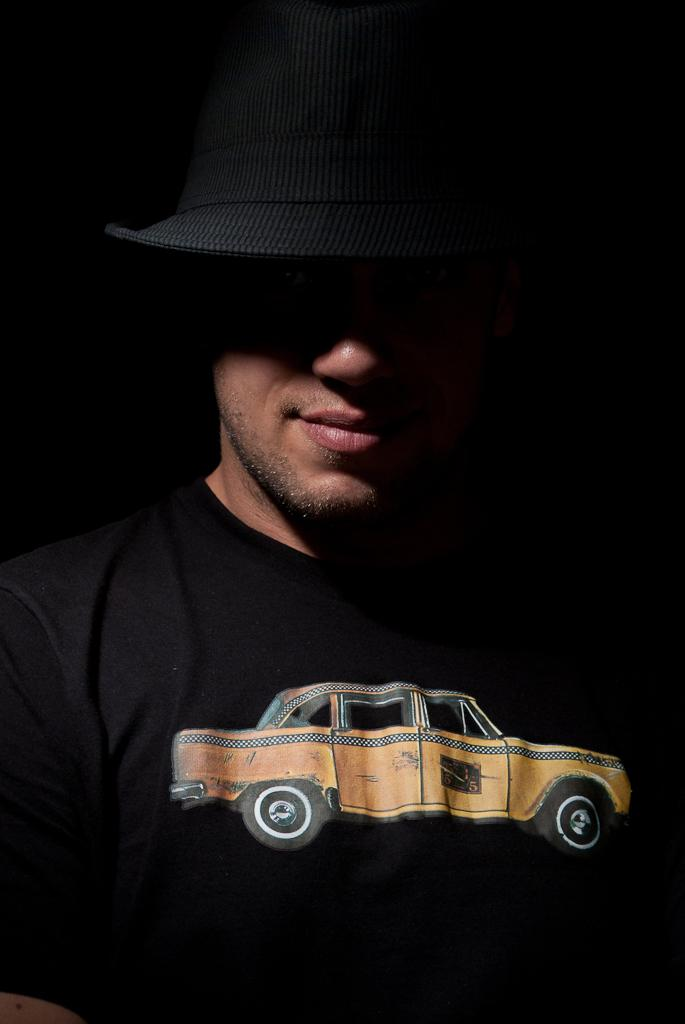What is present in the image? There is a person in the image. What is the person wearing on their upper body? The person is wearing a black shirt. What is the person wearing on their head? The person is wearing a black cap. What design is on the shirt? There is a car painting on the shirt. What time does the clock on the person's wrist show in the image? There is no clock visible on the person's wrist in the image. 